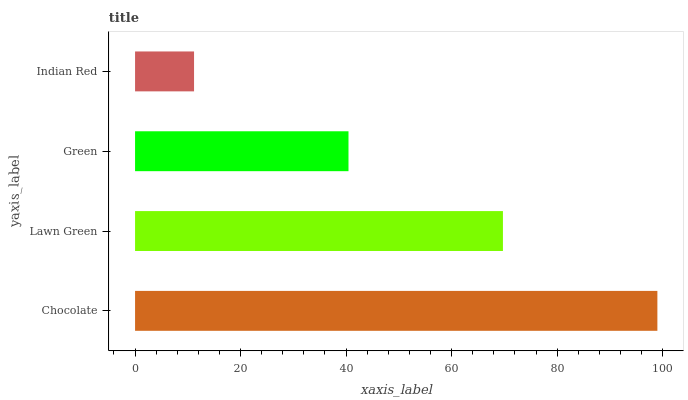Is Indian Red the minimum?
Answer yes or no. Yes. Is Chocolate the maximum?
Answer yes or no. Yes. Is Lawn Green the minimum?
Answer yes or no. No. Is Lawn Green the maximum?
Answer yes or no. No. Is Chocolate greater than Lawn Green?
Answer yes or no. Yes. Is Lawn Green less than Chocolate?
Answer yes or no. Yes. Is Lawn Green greater than Chocolate?
Answer yes or no. No. Is Chocolate less than Lawn Green?
Answer yes or no. No. Is Lawn Green the high median?
Answer yes or no. Yes. Is Green the low median?
Answer yes or no. Yes. Is Indian Red the high median?
Answer yes or no. No. Is Chocolate the low median?
Answer yes or no. No. 